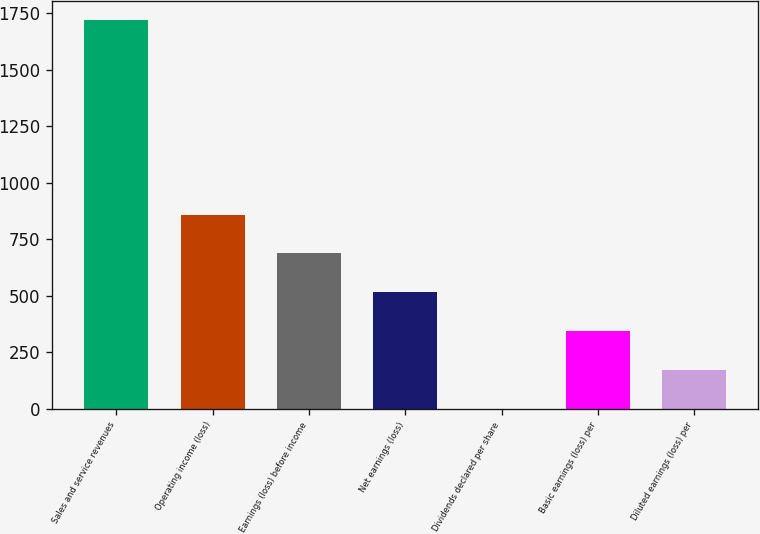<chart> <loc_0><loc_0><loc_500><loc_500><bar_chart><fcel>Sales and service revenues<fcel>Operating income (loss)<fcel>Earnings (loss) before income<fcel>Net earnings (loss)<fcel>Dividends declared per share<fcel>Basic earnings (loss) per<fcel>Diluted earnings (loss) per<nl><fcel>1717<fcel>858.6<fcel>686.92<fcel>515.24<fcel>0.2<fcel>343.56<fcel>171.88<nl></chart> 